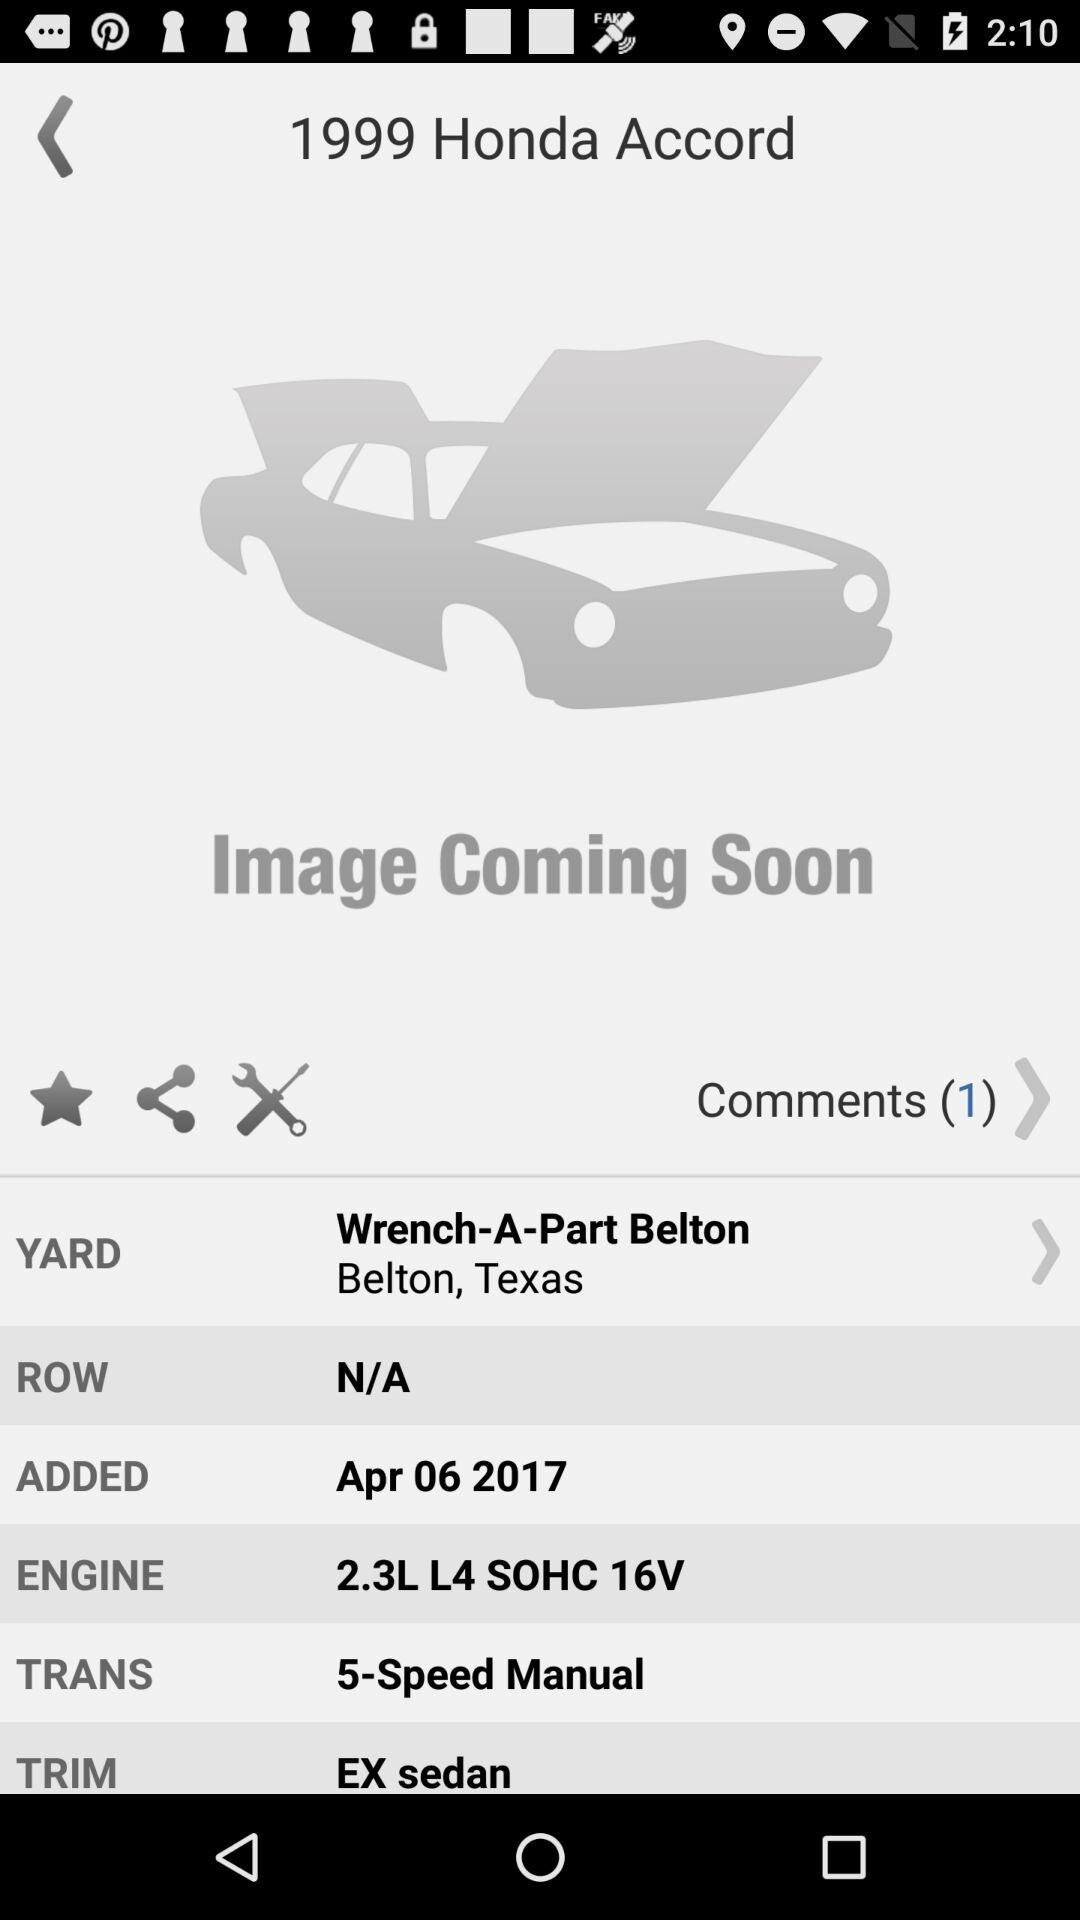What is the Honda Accord's trim? The Honda Accord's trim is EX Sedan. 